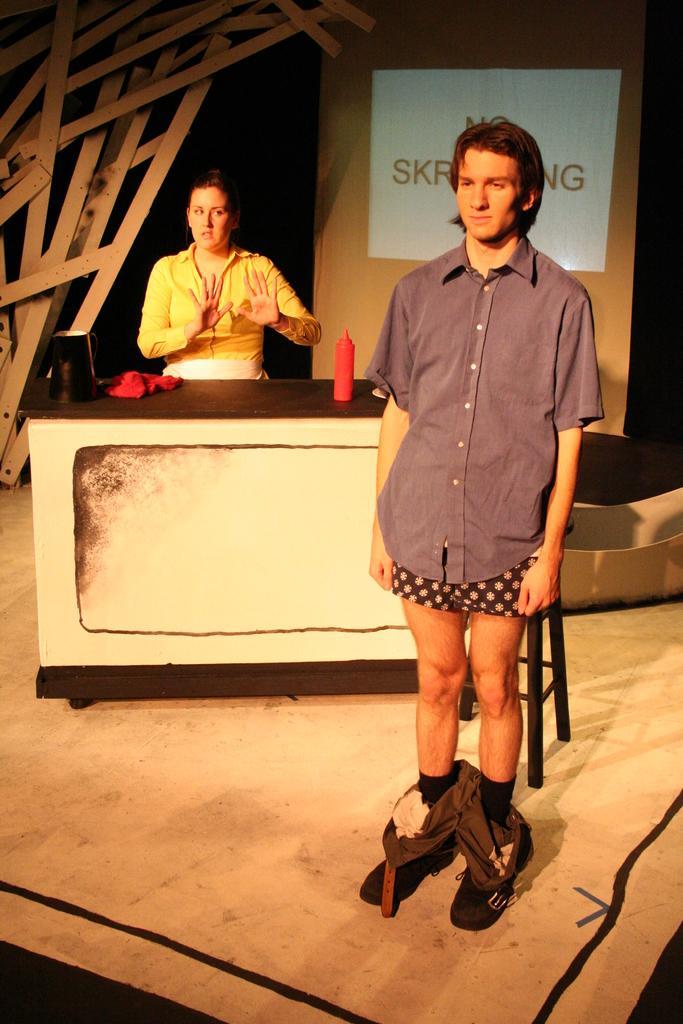Describe this image in one or two sentences. There is a man standing,behind this man we can see bottle and objects on the table and there is a woman. Background we can see screen. 